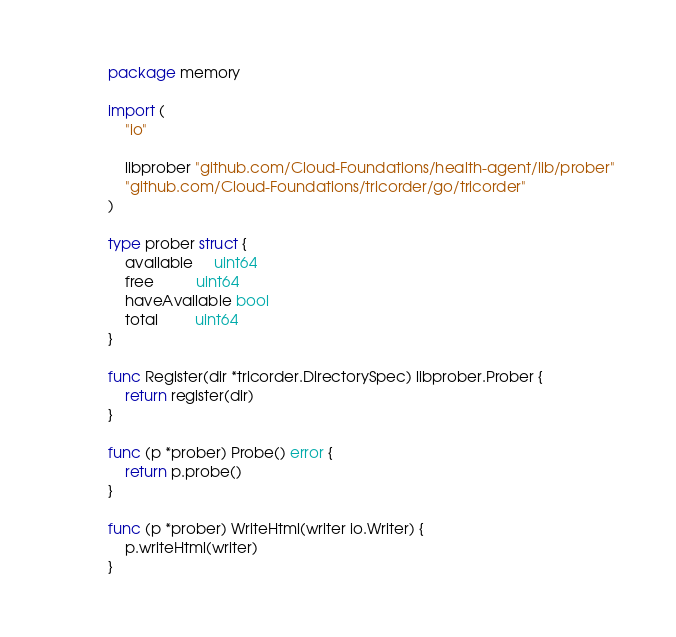<code> <loc_0><loc_0><loc_500><loc_500><_Go_>package memory

import (
	"io"

	libprober "github.com/Cloud-Foundations/health-agent/lib/prober"
	"github.com/Cloud-Foundations/tricorder/go/tricorder"
)

type prober struct {
	available     uint64
	free          uint64
	haveAvailable bool
	total         uint64
}

func Register(dir *tricorder.DirectorySpec) libprober.Prober {
	return register(dir)
}

func (p *prober) Probe() error {
	return p.probe()
}

func (p *prober) WriteHtml(writer io.Writer) {
	p.writeHtml(writer)
}
</code> 